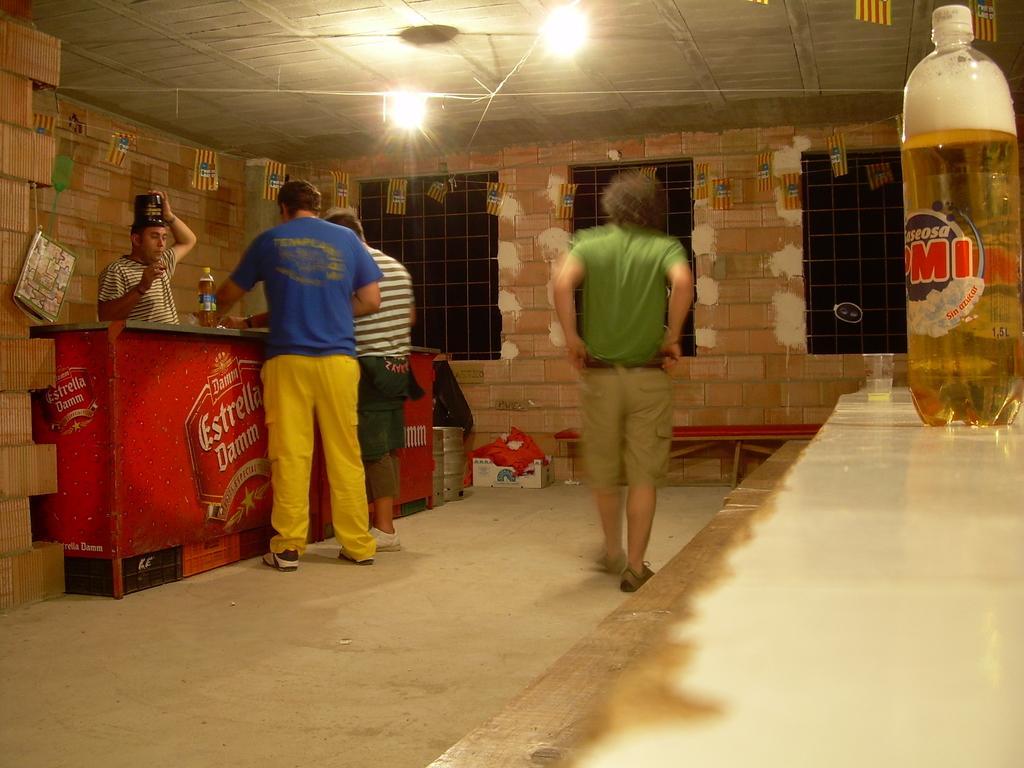Could you give a brief overview of what you see in this image? This is the picture of the inside of the room. The 4 persons are in the room. The 3 persons are standing in front of table. The check shirt person is holding like cap. There is bottle on the table. The right side of the person is walking. There is a another bottle on the another table. We can see on the background there is windows,some wall bricks and lights. 